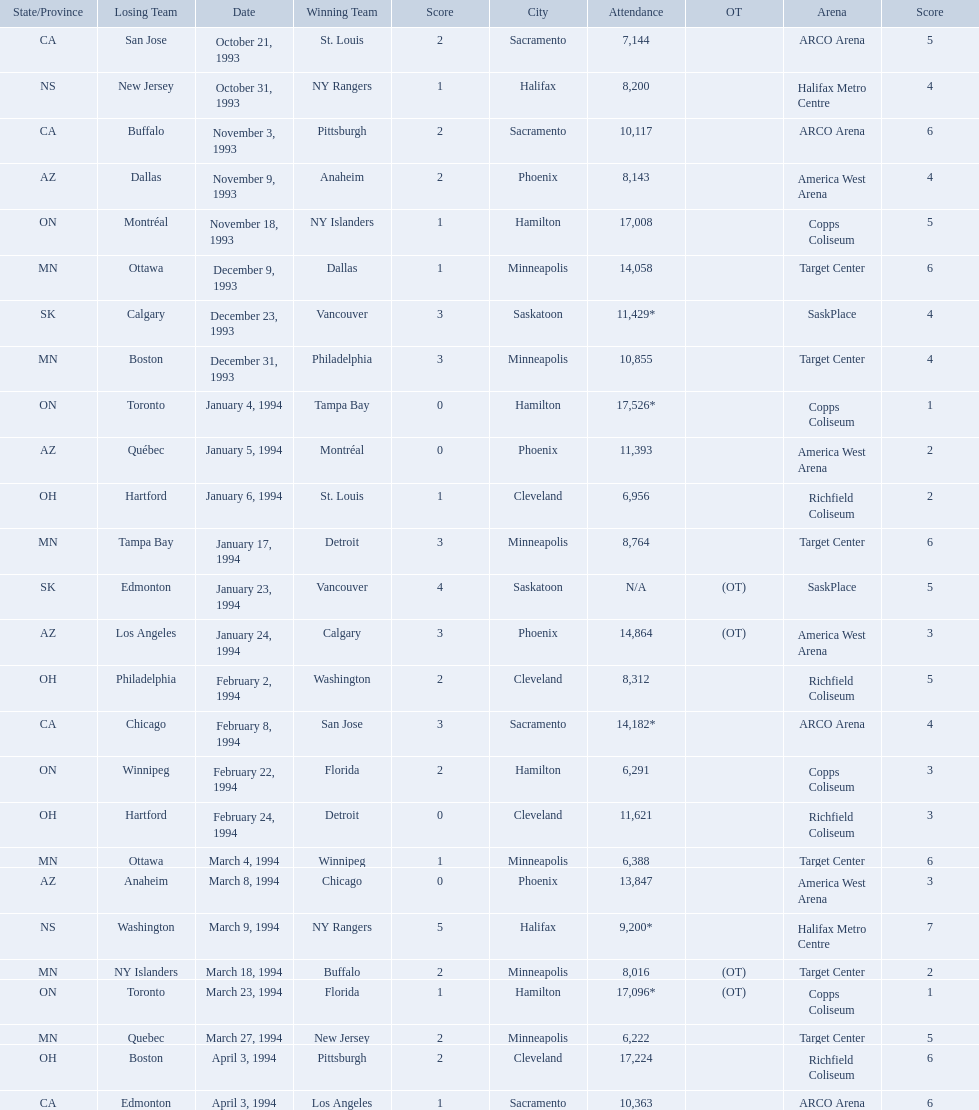Which dates saw the winning team score only one point? January 4, 1994, March 23, 1994. Of these two, which date had higher attendance? January 4, 1994. 